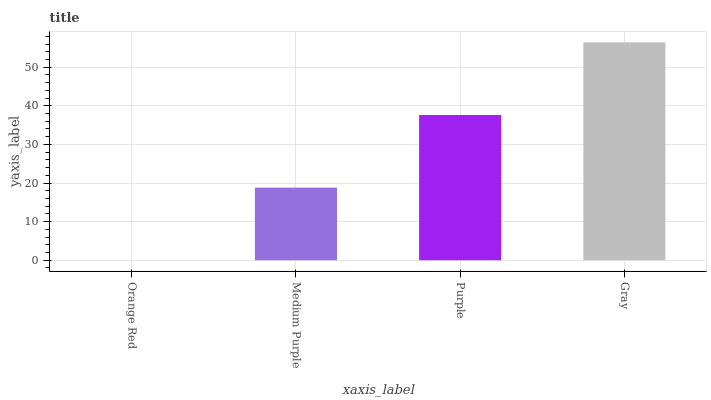Is Orange Red the minimum?
Answer yes or no. Yes. Is Gray the maximum?
Answer yes or no. Yes. Is Medium Purple the minimum?
Answer yes or no. No. Is Medium Purple the maximum?
Answer yes or no. No. Is Medium Purple greater than Orange Red?
Answer yes or no. Yes. Is Orange Red less than Medium Purple?
Answer yes or no. Yes. Is Orange Red greater than Medium Purple?
Answer yes or no. No. Is Medium Purple less than Orange Red?
Answer yes or no. No. Is Purple the high median?
Answer yes or no. Yes. Is Medium Purple the low median?
Answer yes or no. Yes. Is Gray the high median?
Answer yes or no. No. Is Orange Red the low median?
Answer yes or no. No. 